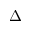<formula> <loc_0><loc_0><loc_500><loc_500>\Delta</formula> 